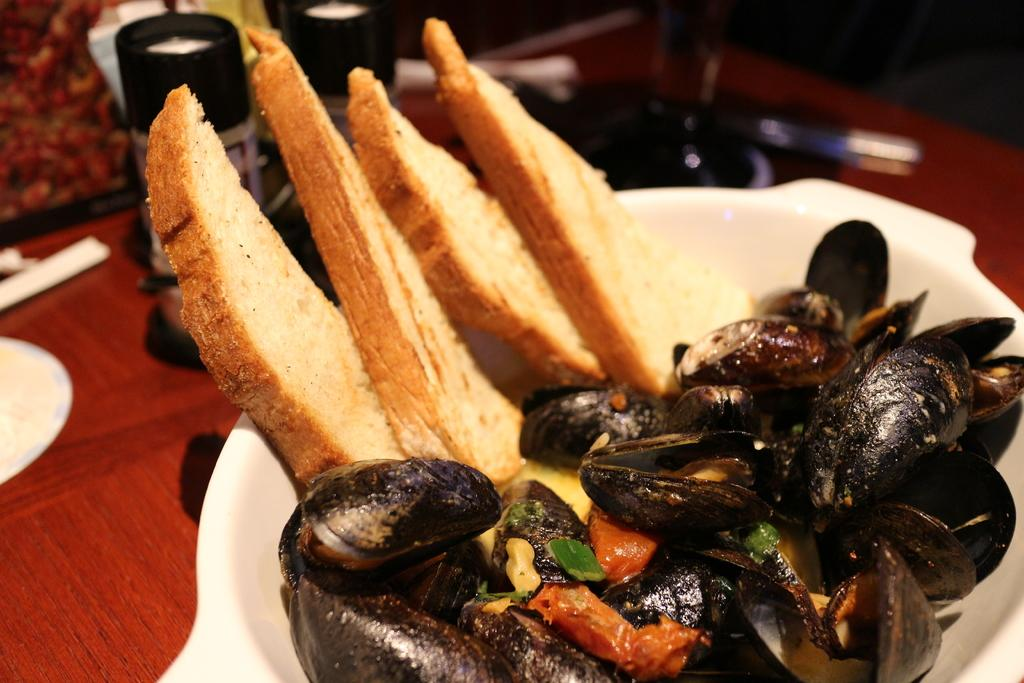What type of food can be seen in the image? There are bread slices and food in a bowl in the image. What is used to serve the food in the image? There is a plate in the image. What else can be seen on the table in the image? There are bottles on the table in the image. What type of gold jewelry can be seen on the bread slices in the image? There is no gold jewelry present on the bread slices in the image. How does the fog affect the visibility of the food in the image? There is no fog present in the image, so it does not affect the visibility of the food. 